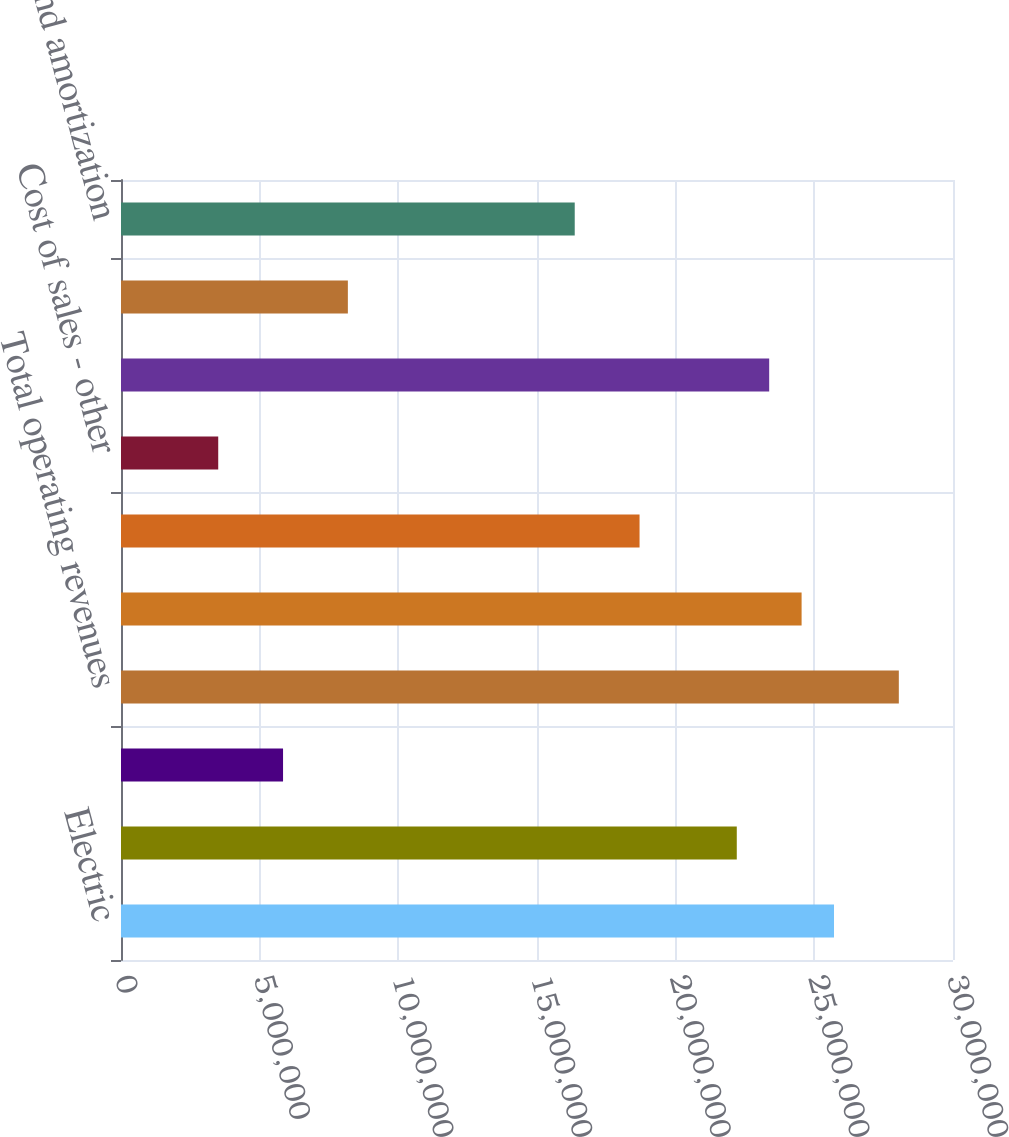Convert chart to OTSL. <chart><loc_0><loc_0><loc_500><loc_500><bar_chart><fcel>Electric<fcel>Natural gas<fcel>Other<fcel>Total operating revenues<fcel>Electric fuel and purchased<fcel>Cost of natural gas sold and<fcel>Cost of sales - other<fcel>Operating and maintenance<fcel>Conservation and demand side<fcel>Depreciation and amortization<nl><fcel>2.57095e+07<fcel>2.22037e+07<fcel>5.84307e+06<fcel>2.80467e+07<fcel>2.45409e+07<fcel>1.86978e+07<fcel>3.50584e+06<fcel>2.33723e+07<fcel>8.18029e+06<fcel>1.63606e+07<nl></chart> 